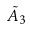<formula> <loc_0><loc_0><loc_500><loc_500>\tilde { A } _ { 3 }</formula> 